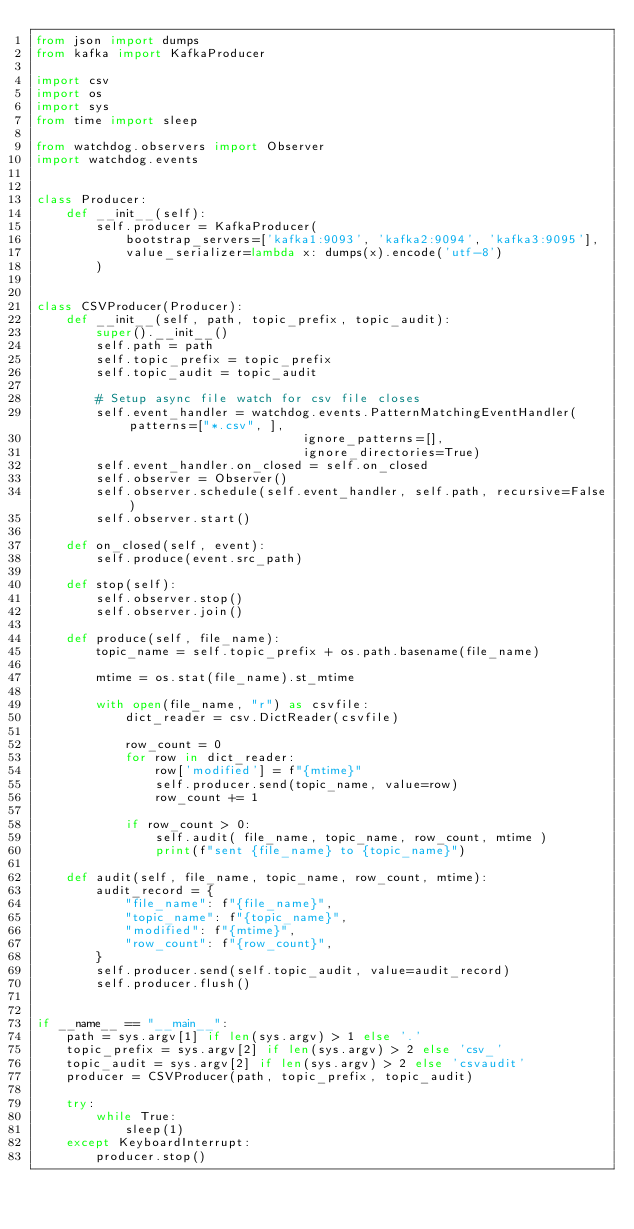Convert code to text. <code><loc_0><loc_0><loc_500><loc_500><_Python_>from json import dumps
from kafka import KafkaProducer

import csv
import os
import sys
from time import sleep

from watchdog.observers import Observer
import watchdog.events


class Producer:
    def __init__(self):
        self.producer = KafkaProducer(
            bootstrap_servers=['kafka1:9093', 'kafka2:9094', 'kafka3:9095'],
            value_serializer=lambda x: dumps(x).encode('utf-8')
        )


class CSVProducer(Producer):
    def __init__(self, path, topic_prefix, topic_audit):
        super().__init__()
        self.path = path
        self.topic_prefix = topic_prefix
        self.topic_audit = topic_audit

        # Setup async file watch for csv file closes
        self.event_handler = watchdog.events.PatternMatchingEventHandler(patterns=["*.csv", ],
                                    ignore_patterns=[],
                                    ignore_directories=True)
        self.event_handler.on_closed = self.on_closed
        self.observer = Observer()
        self.observer.schedule(self.event_handler, self.path, recursive=False)
        self.observer.start()

    def on_closed(self, event):
        self.produce(event.src_path)

    def stop(self):
        self.observer.stop()
        self.observer.join()

    def produce(self, file_name):
        topic_name = self.topic_prefix + os.path.basename(file_name)

        mtime = os.stat(file_name).st_mtime

        with open(file_name, "r") as csvfile:
            dict_reader = csv.DictReader(csvfile)

            row_count = 0
            for row in dict_reader:
                row['modified'] = f"{mtime}"
                self.producer.send(topic_name, value=row)
                row_count += 1

            if row_count > 0:
                self.audit( file_name, topic_name, row_count, mtime )
                print(f"sent {file_name} to {topic_name}")

    def audit(self, file_name, topic_name, row_count, mtime):
        audit_record = {
            "file_name": f"{file_name}",
            "topic_name": f"{topic_name}",
            "modified": f"{mtime}",
            "row_count": f"{row_count}",
        }
        self.producer.send(self.topic_audit, value=audit_record)
        self.producer.flush()


if __name__ == "__main__":
    path = sys.argv[1] if len(sys.argv) > 1 else '.'
    topic_prefix = sys.argv[2] if len(sys.argv) > 2 else 'csv_'
    topic_audit = sys.argv[2] if len(sys.argv) > 2 else 'csvaudit'
    producer = CSVProducer(path, topic_prefix, topic_audit)
    
    try:
        while True:
            sleep(1)
    except KeyboardInterrupt:
        producer.stop()

</code> 